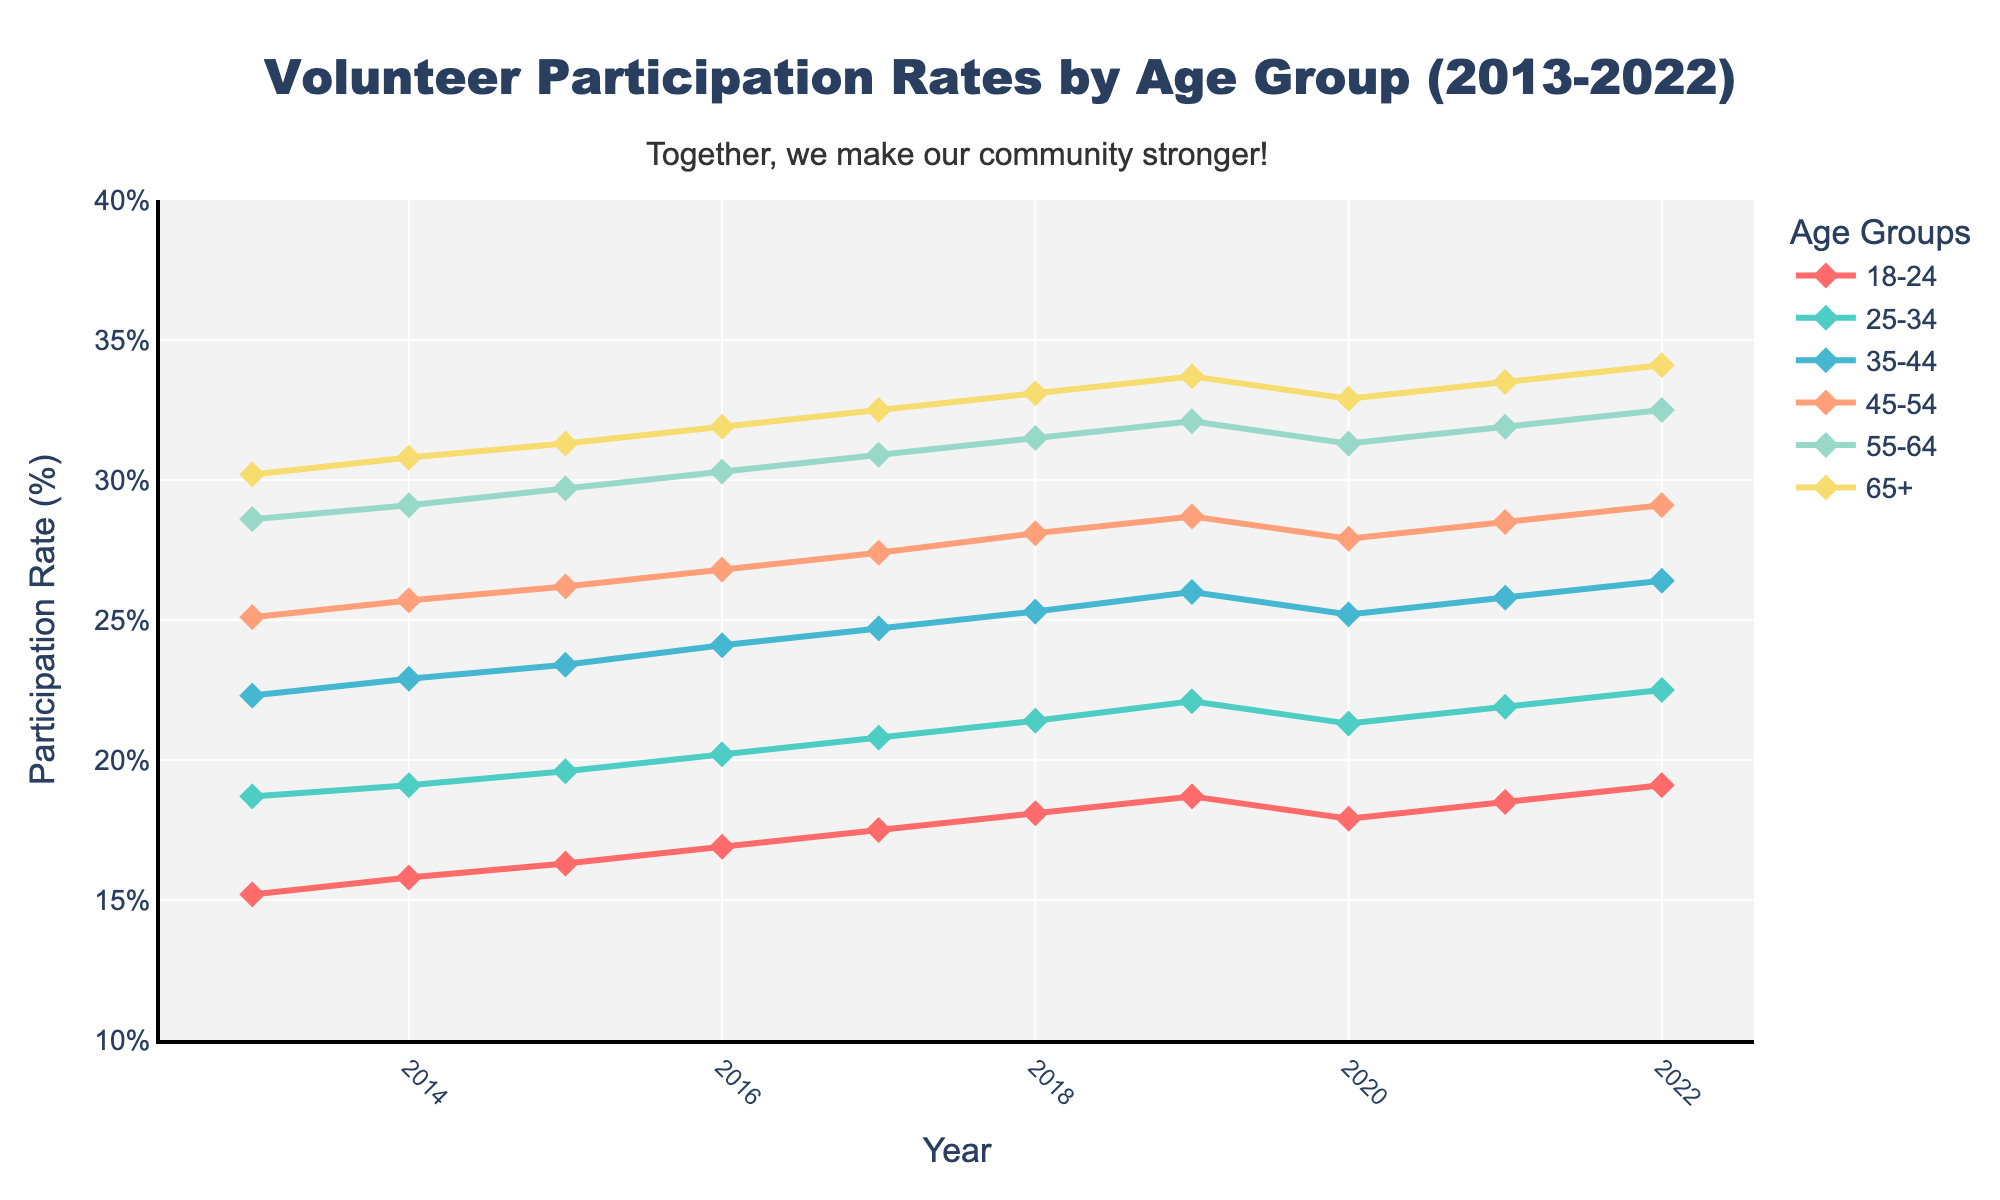What was the participation rate for the 18-24 age group in 2013? Look at the '18-24' line in the plot and refer to the data point for the year 2013. The participation rate is marked by the symbol at this point.
Answer: 15.2% Which age group had the highest participation rate in 2020? Compare the data points for all age groups in the year 2020. The highest point belongs to the 65+ age group.
Answer: 65+ How much did the participation rate for the 25-34 age group increase between 2013 and 2022? Find the values for the 25-34 age group in 2013 and 2022. Subtract the 2013 value from the 2022 value: 22.5 - 18.7.
Answer: 3.8% Which two age groups had the smallest difference in participation rates in 2018? Compare the 2018 values for all age groups and find the two groups with the closest values by calculating the absolute differences. The smallest difference is between the 45-54 and 55-64 groups:
Answer: 45-54 and 55-64 What is the overall trend for volunteer participation rates in the 35-44 age group from 2013 to 2022? Examine the trend line for the 35-44 age group by observing if it generally goes up or down. The line trends upward consistently.
Answer: Increasing By how much did the participation rate for the 65+ age group decrease from 2019 to 2020? Find the values for the 65+ age group from 2019 and 2020. Subtract the 2020 value from the 2019 value: 33.7 - 32.9.
Answer: 0.8% What was the average participation rate for the 45-54 age group over the decade? Sum the participation rates for the 45-54 age group for all years (25.1 + 25.7 + 26.2 + 26.8 + 27.4 + 28.1 + 28.7 + 27.9 + 28.5 + 29.1) and then divide by the number of years (10). (274.5 / 10)
Answer: 27.45% Which age group had the most steady increase in participation rate over the years, without any drop? Examine the lines closely for consistency in upward movement by checking if there are no drops from year to year. The 55-64 age group shows a steady increase without any drops.
Answer: 55-64 In what year did the 18-24 age group see the biggest jump in participation rate? Find the year with the largest increase by comparing consecutive years. The biggest jump is from 2018 to 2019 (18.1% to 18.7%).
Answer: 2019 What is the difference between the highest and lowest participation rates recorded among all ages in 2022? Find the highest and lowest rates in 2022, then subtract the lowest rate (19.1% for 18-24 age) from the highest rate (34.1% for 65+ age): 34.1 - 19.1.
Answer: 15% 